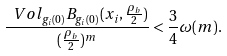<formula> <loc_0><loc_0><loc_500><loc_500>\frac { \ V o l _ { g _ { i } ( 0 ) } B _ { g _ { i } ( 0 ) } ( x _ { i } , \frac { \rho _ { b } } { 2 } ) } { ( \frac { \rho _ { b } } { 2 } ) ^ { m } } < \frac { 3 } { 4 } \omega ( m ) .</formula> 